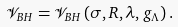<formula> <loc_0><loc_0><loc_500><loc_500>\mathcal { V } _ { B H } = \mathcal { V } _ { B H } \left ( \sigma , R , \lambda , g _ { \Lambda } \right ) .</formula> 